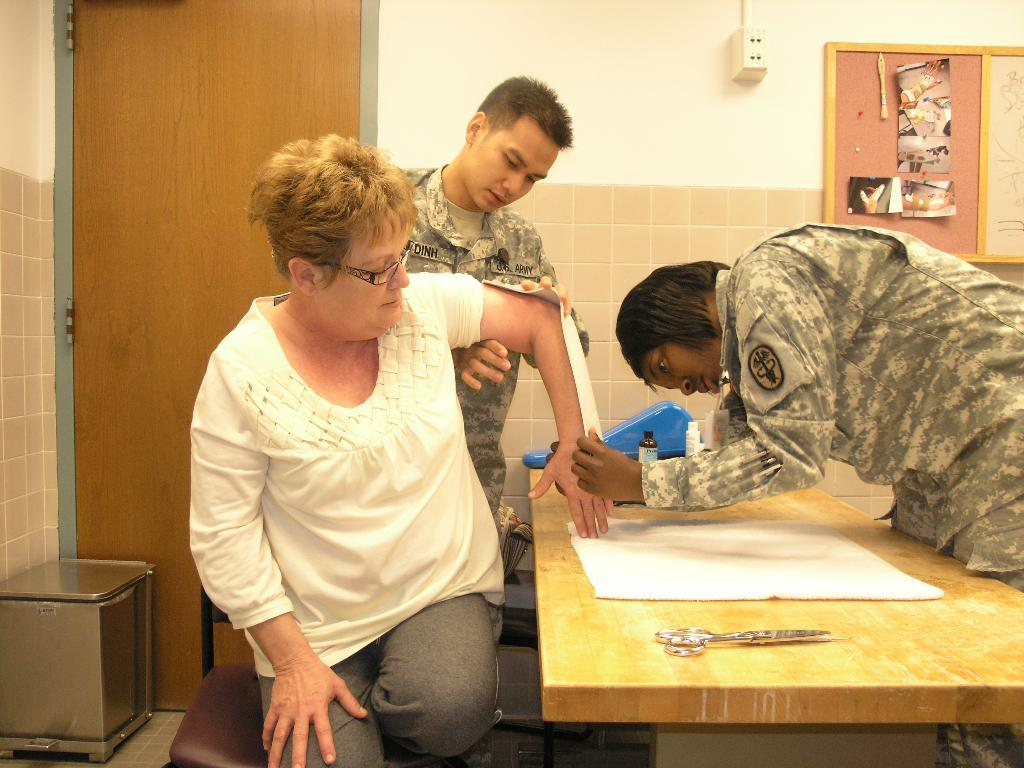How many people are present in the image? There are three people in the image. What object can be seen in the image that is typically used for cutting? There is a scissor in the image. What is the scissor being used on in the image? The scissor is being used on a paper in the image. What is on the table in the image? There are objects on the table, including a box and a notice board. What is the purpose of the socket in the image? The socket is likely used for plugging in electrical devices. What type of quince is being used as an ornament on the notice board in the image? There is no quince present in the image, let alone being used as an ornament on the notice board. 